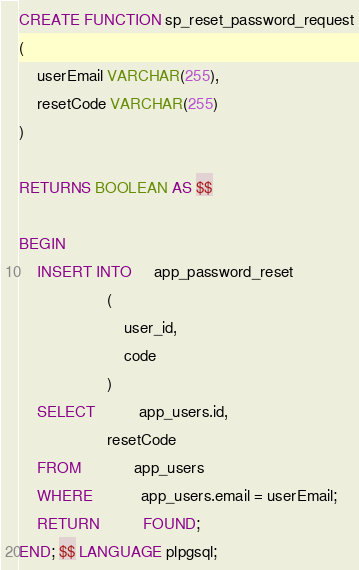<code> <loc_0><loc_0><loc_500><loc_500><_SQL_>CREATE FUNCTION sp_reset_password_request
(
    userEmail VARCHAR(255),
    resetCode VARCHAR(255)
)

RETURNS BOOLEAN AS $$

BEGIN
    INSERT INTO     app_password_reset
                    (
                        user_id,
                        code
                    )
    SELECT          app_users.id,
                    resetCode
    FROM            app_users
    WHERE           app_users.email = userEmail;
    RETURN          FOUND;
END; $$ LANGUAGE plpgsql;
</code> 